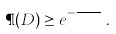Convert formula to latex. <formula><loc_0><loc_0><loc_500><loc_500>\P ( D ) \geq e ^ { - \frac { C } { \ e p s } } \, .</formula> 